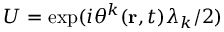Convert formula to latex. <formula><loc_0><loc_0><loc_500><loc_500>U = \exp ( i \theta ^ { k } ( { r } , t ) \lambda _ { k } / 2 )</formula> 